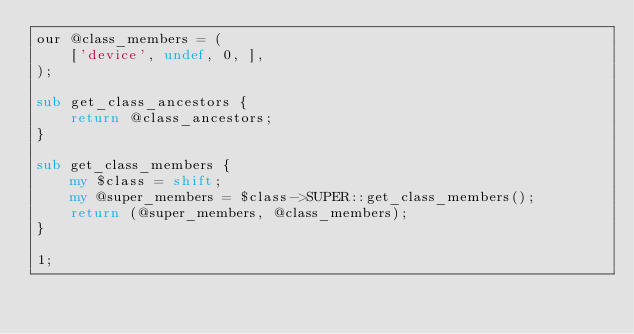<code> <loc_0><loc_0><loc_500><loc_500><_Perl_>our @class_members = ( 
    ['device', undef, 0, ],
);

sub get_class_ancestors {
    return @class_ancestors;
}

sub get_class_members {
    my $class = shift;
    my @super_members = $class->SUPER::get_class_members();
    return (@super_members, @class_members);
}

1;
</code> 